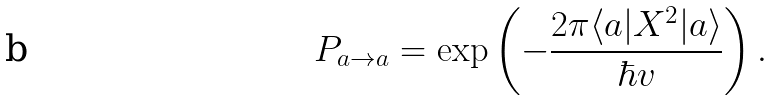<formula> <loc_0><loc_0><loc_500><loc_500>P _ { a \to a } = \exp \left ( - \frac { 2 \pi \langle a | X ^ { 2 } | a \rangle } { \hbar { v } } \right ) .</formula> 